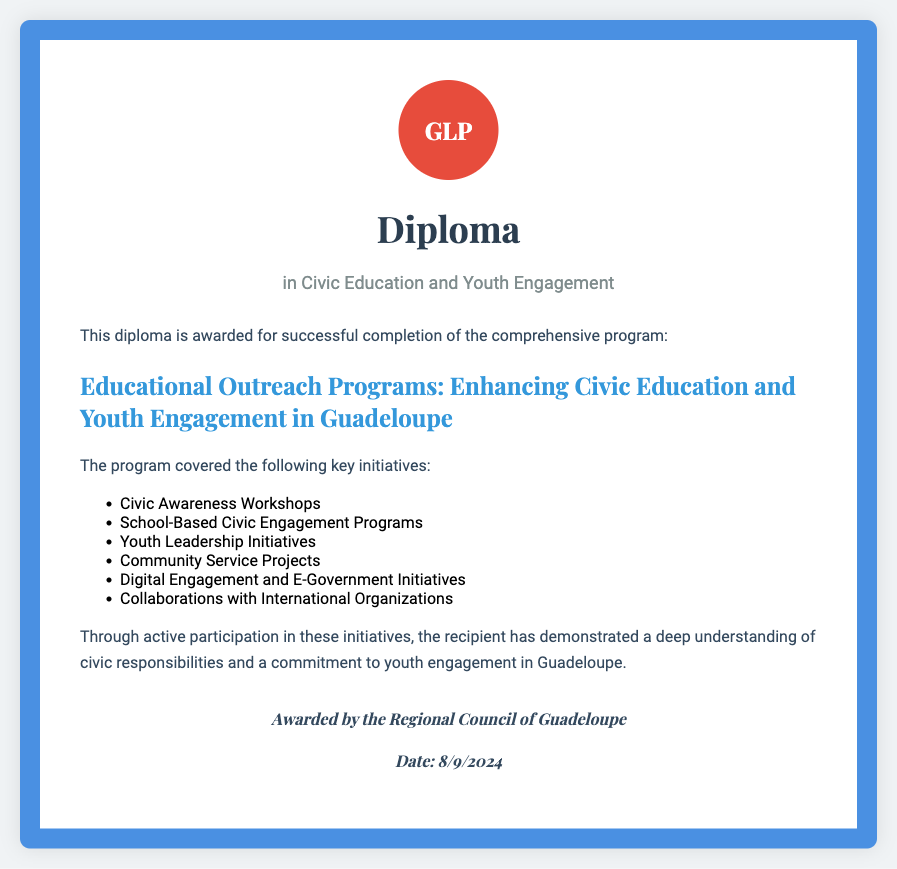What is the title of the diploma? The title specifies the subject area of the diploma, which is Civic Education and Youth Engagement.
Answer: Diploma in Civic Education and Youth Engagement Who awarded the diploma? The awarding authority is mentioned at the bottom of the document.
Answer: Regional Council of Guadeloupe How many key initiatives are listed in the program? The number of initiatives is provided in the content section of the diploma.
Answer: Six What is the first initiative mentioned? The first initiative is listed in the bullet points detailing the program.
Answer: Civic Awareness Workshops What is the date of awarding? The date is dynamically generated in the document based on the current date.
Answer: Current date What kind of workshops are included in the initiatives? The type of workshops reflects the educational focus of the program.
Answer: Civic Awareness Workshops What does the recipient demonstrate through participation? This statement reflects the recipient's understanding and commitment outlined in the diploma.
Answer: Deep understanding of civic responsibilities and a commitment to youth engagement Which two key areas are highlighted in the subtitle? The subtitle emphasizes the main themes of the diploma, which are education and engagement.
Answer: Educational Outreach Programs, Youth Engagement 